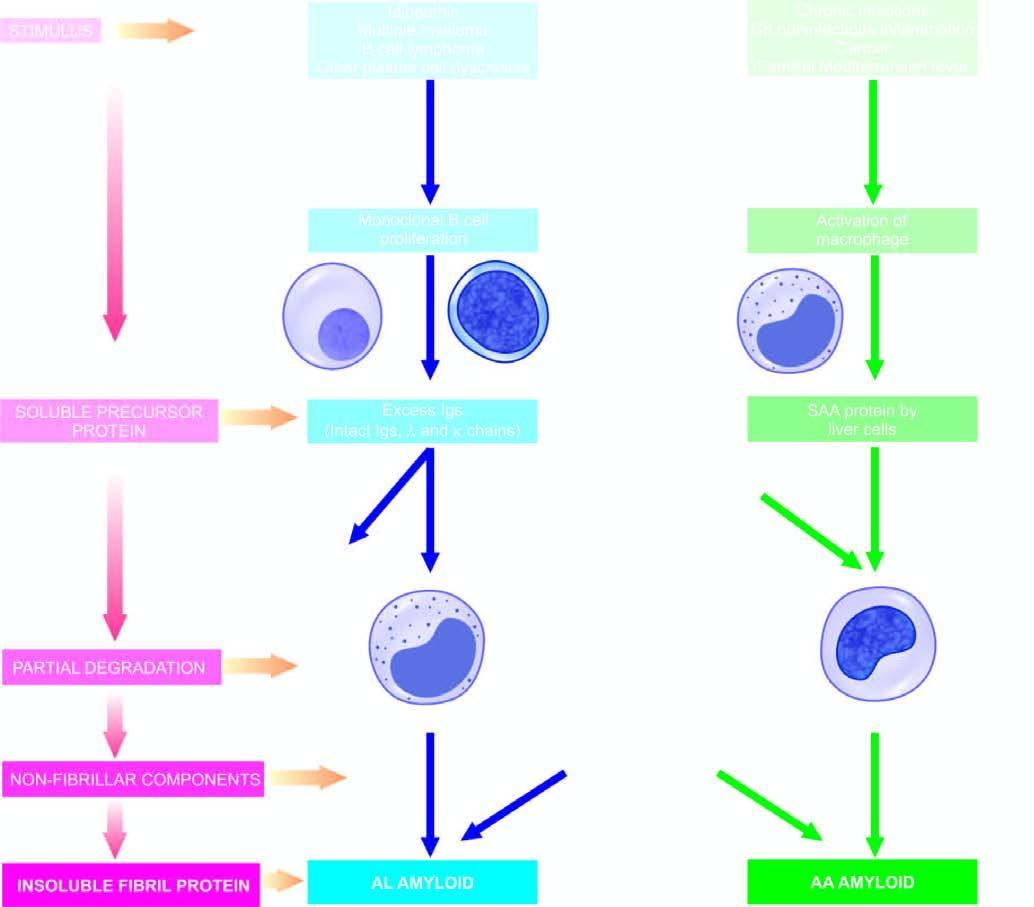does the sequence on left show general schematic representation common to both major forms of amyloidogenesis?
Answer the question using a single word or phrase. Yes 